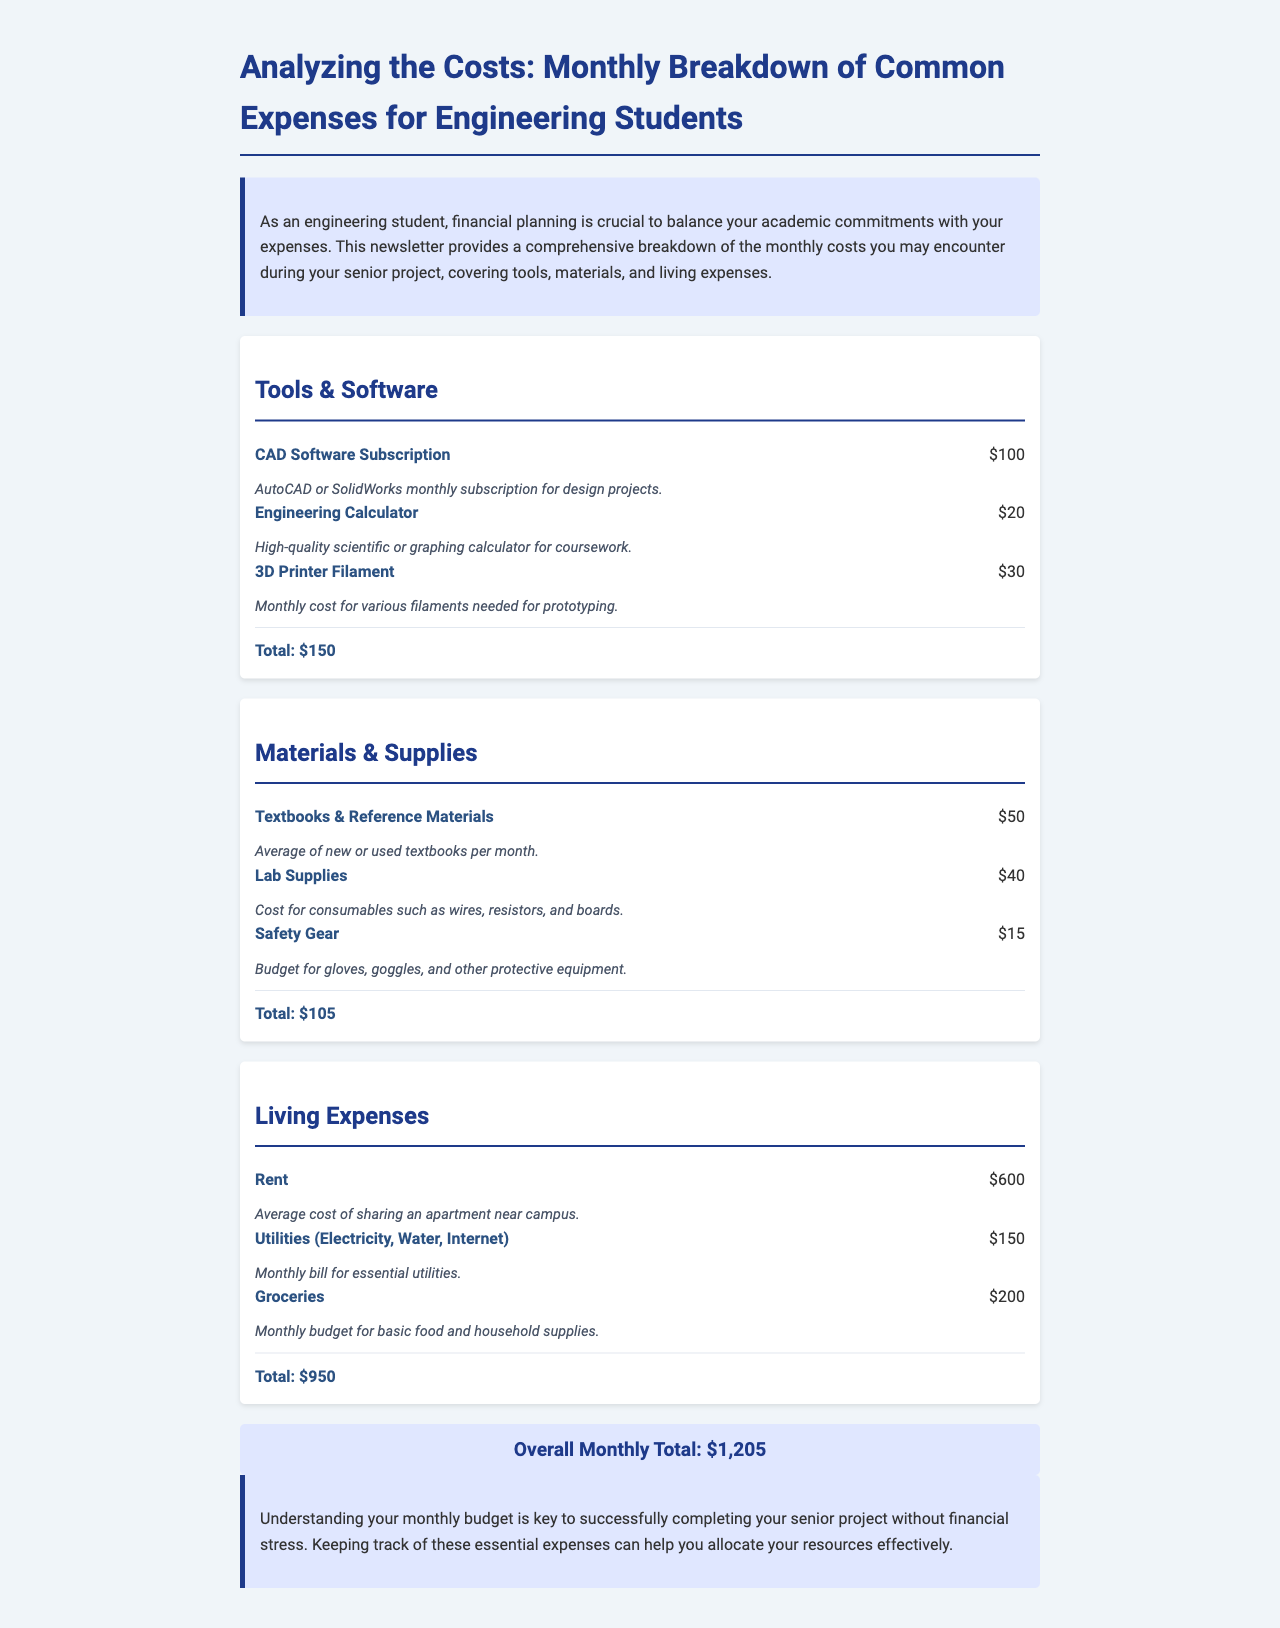What is the total cost for Tools & Software? The total cost for Tools & Software is provided in the category section, which accumulates to $150.
Answer: $150 What materials are included under Materials & Supplies? The newsletter describes three materials under Materials & Supplies: Textbooks & Reference Materials, Lab Supplies, and Safety Gear.
Answer: Textbooks & Reference Materials, Lab Supplies, Safety Gear How much do groceries cost monthly? The mentioned monthly budget for groceries in the Living Expenses section is stated clearly as $200.
Answer: $200 What is the total overall monthly cost? The overall cost is summarized at the end of the document as the sum of all categories, which totals $1,205.
Answer: $1,205 How much is spent on Utilities? The document specifies that the monthly bill for Utilities, including electricity, water, and internet, is $150.
Answer: $150 Which tool has the highest cost in the Tools & Software category? The cost breakdown shows that the CAD Software Subscription has the highest cost at $100.
Answer: CAD Software Subscription What is the monthly cost for Safety Gear? The document lists the monthly budget for Safety Gear under Materials & Supplies as $15.
Answer: $15 How many categories of expenses are mentioned in the document? The document outlines three main categories of expenses: Tools & Software, Materials & Supplies, and Living Expenses.
Answer: Three 